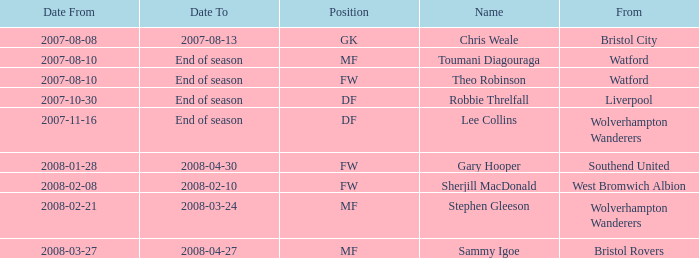What was the label for the row having a "date from" of 2008-02-21? Stephen Gleeson. 